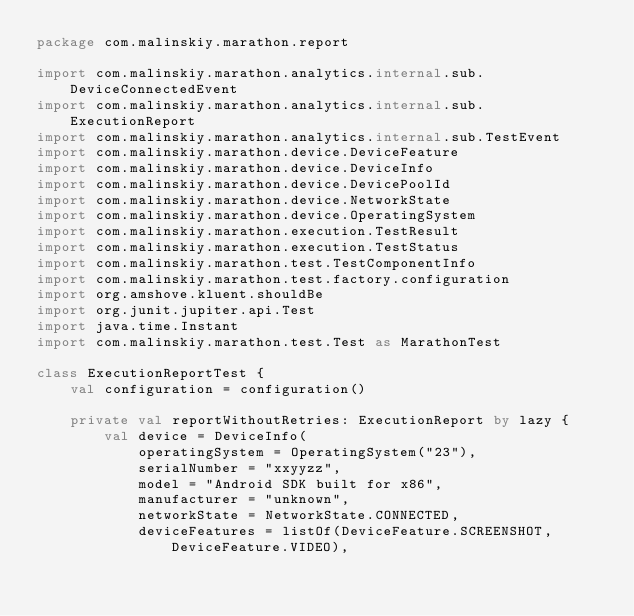Convert code to text. <code><loc_0><loc_0><loc_500><loc_500><_Kotlin_>package com.malinskiy.marathon.report

import com.malinskiy.marathon.analytics.internal.sub.DeviceConnectedEvent
import com.malinskiy.marathon.analytics.internal.sub.ExecutionReport
import com.malinskiy.marathon.analytics.internal.sub.TestEvent
import com.malinskiy.marathon.device.DeviceFeature
import com.malinskiy.marathon.device.DeviceInfo
import com.malinskiy.marathon.device.DevicePoolId
import com.malinskiy.marathon.device.NetworkState
import com.malinskiy.marathon.device.OperatingSystem
import com.malinskiy.marathon.execution.TestResult
import com.malinskiy.marathon.execution.TestStatus
import com.malinskiy.marathon.test.TestComponentInfo
import com.malinskiy.marathon.test.factory.configuration
import org.amshove.kluent.shouldBe
import org.junit.jupiter.api.Test
import java.time.Instant
import com.malinskiy.marathon.test.Test as MarathonTest

class ExecutionReportTest {
    val configuration = configuration()

    private val reportWithoutRetries: ExecutionReport by lazy {
        val device = DeviceInfo(
            operatingSystem = OperatingSystem("23"),
            serialNumber = "xxyyzz",
            model = "Android SDK built for x86",
            manufacturer = "unknown",
            networkState = NetworkState.CONNECTED,
            deviceFeatures = listOf(DeviceFeature.SCREENSHOT, DeviceFeature.VIDEO),</code> 